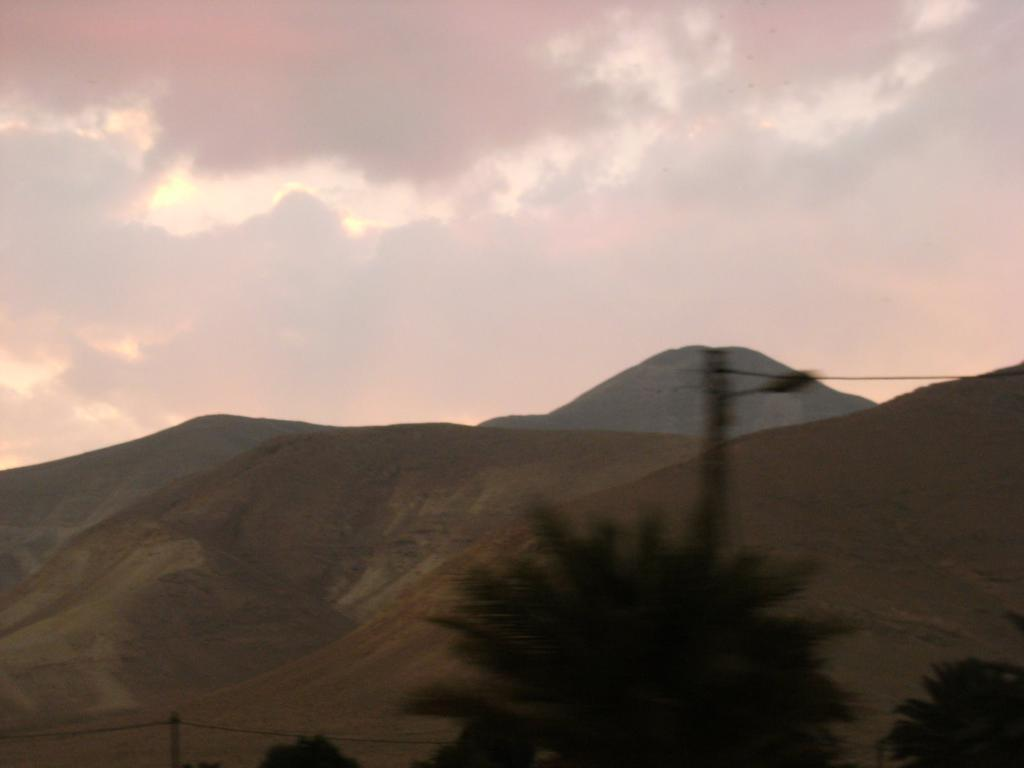What type of vegetation can be seen in the front of the image? There are trees in the front of the image. What type of landscape feature is visible in the image? There are hills visible in the image. What part of the natural environment is visible in the image? The sky is visible in the image. What can be observed in the sky? Clouds are present in the sky. Are there any houses visible during recess on the farm in the image? There is no reference to houses, recess, or a farm in the image. The image features trees, hills, and a sky with clouds. 